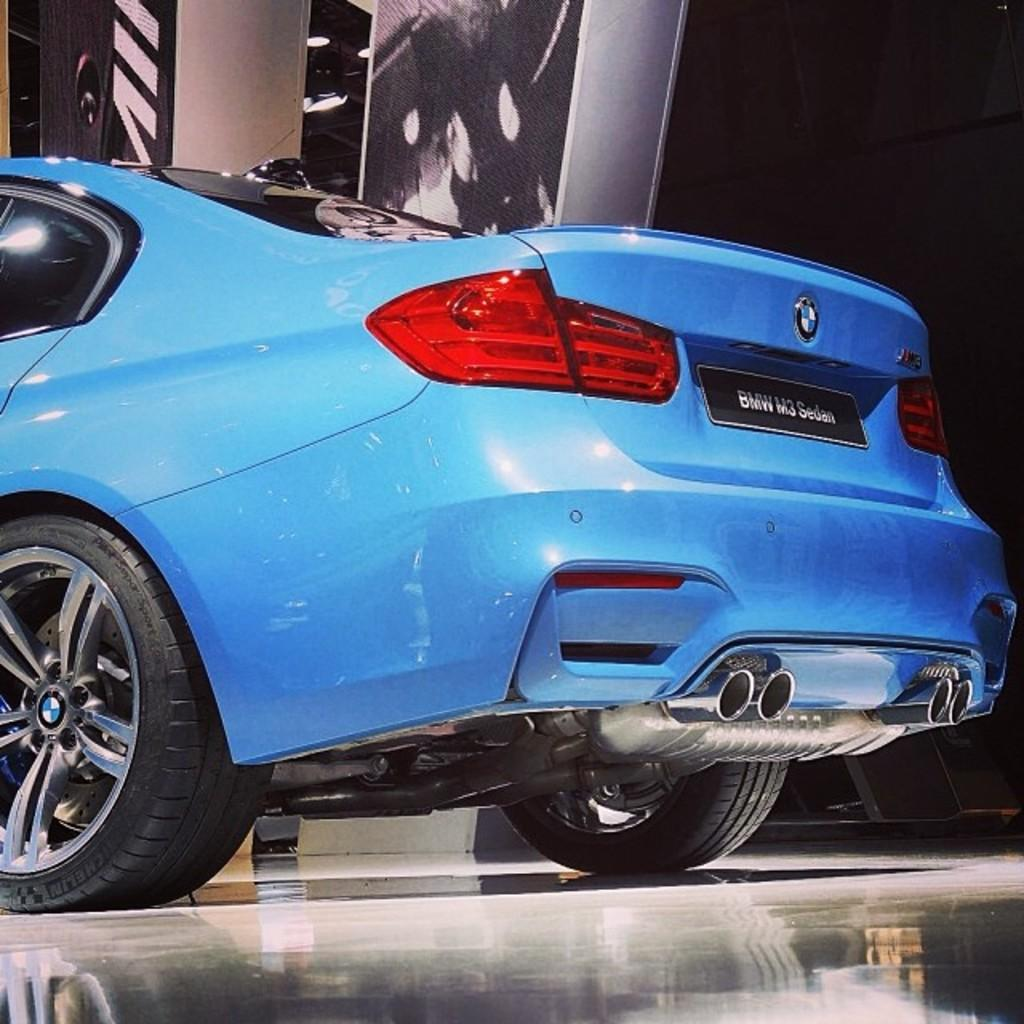What is the main subject of the image? The main subject of the image is a car. Where is the car located in the image? The car is on the floor in the image. What can be seen in the background of the image? There is a wall in the background of the image. How many kittens are playing with balls on the tree in the image? There are no kittens, balls, or trees present in the image. 